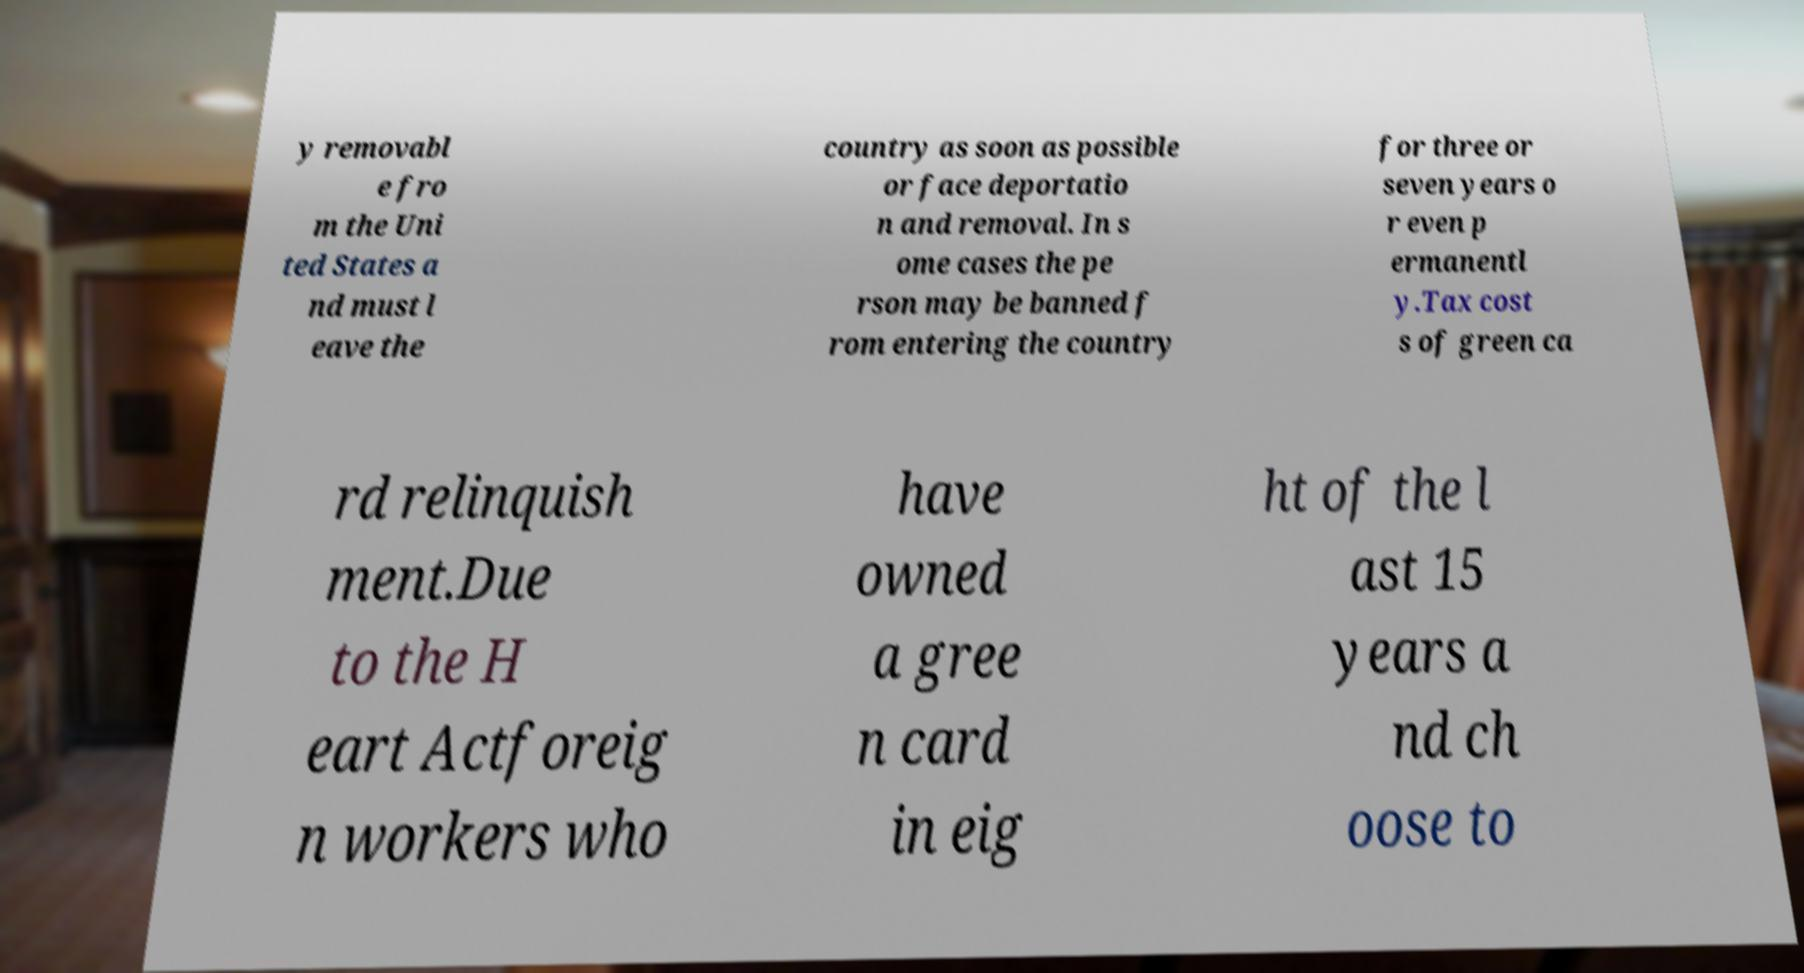Can you accurately transcribe the text from the provided image for me? y removabl e fro m the Uni ted States a nd must l eave the country as soon as possible or face deportatio n and removal. In s ome cases the pe rson may be banned f rom entering the country for three or seven years o r even p ermanentl y.Tax cost s of green ca rd relinquish ment.Due to the H eart Actforeig n workers who have owned a gree n card in eig ht of the l ast 15 years a nd ch oose to 